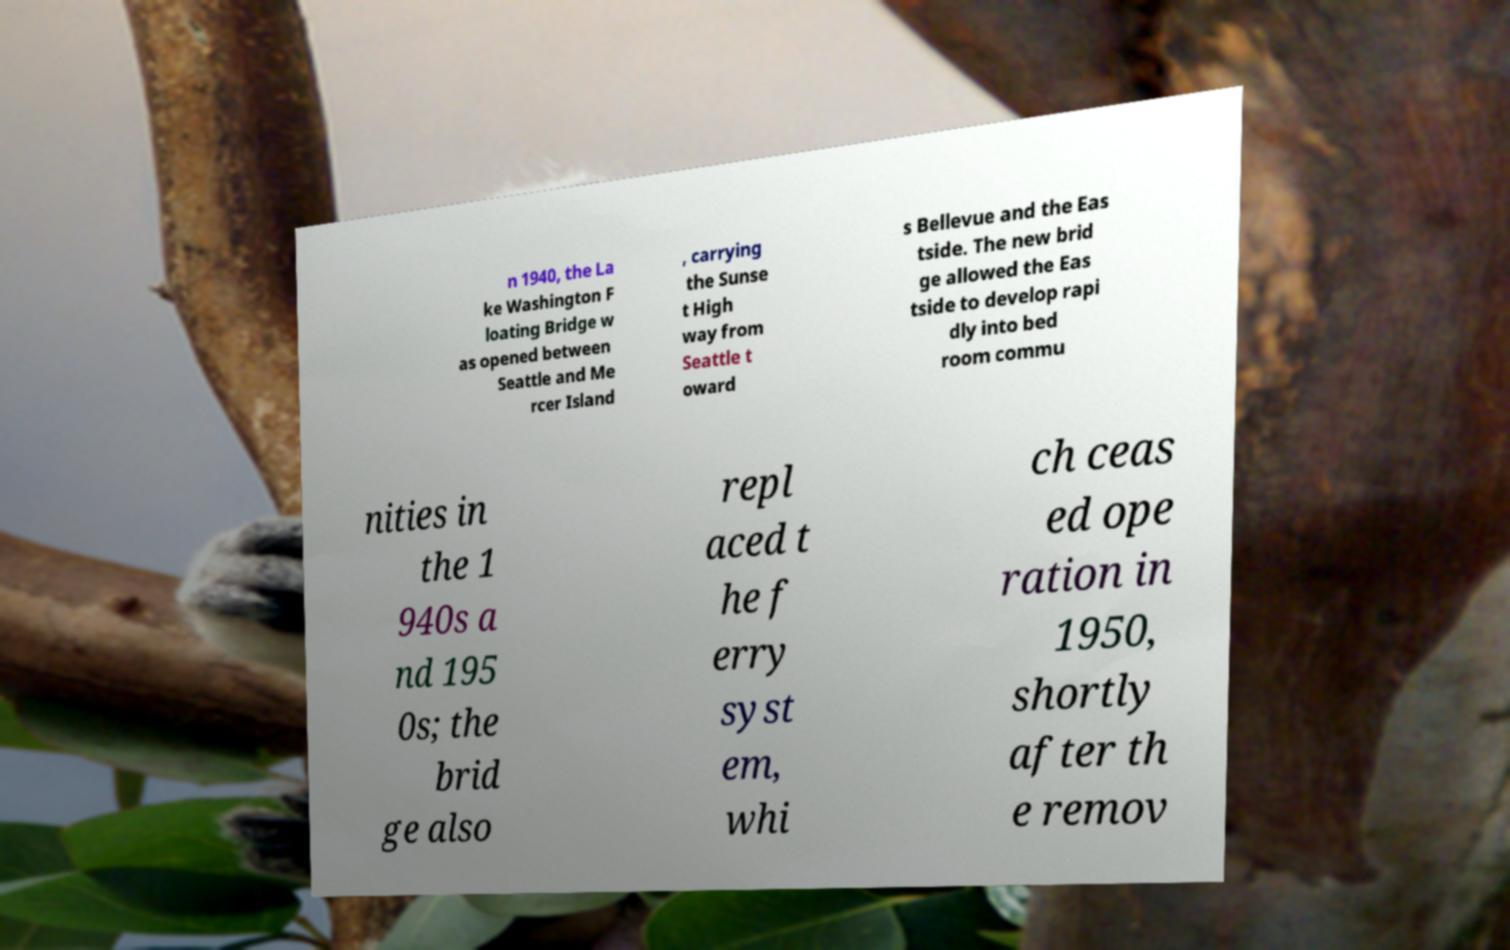Can you accurately transcribe the text from the provided image for me? n 1940, the La ke Washington F loating Bridge w as opened between Seattle and Me rcer Island , carrying the Sunse t High way from Seattle t oward s Bellevue and the Eas tside. The new brid ge allowed the Eas tside to develop rapi dly into bed room commu nities in the 1 940s a nd 195 0s; the brid ge also repl aced t he f erry syst em, whi ch ceas ed ope ration in 1950, shortly after th e remov 